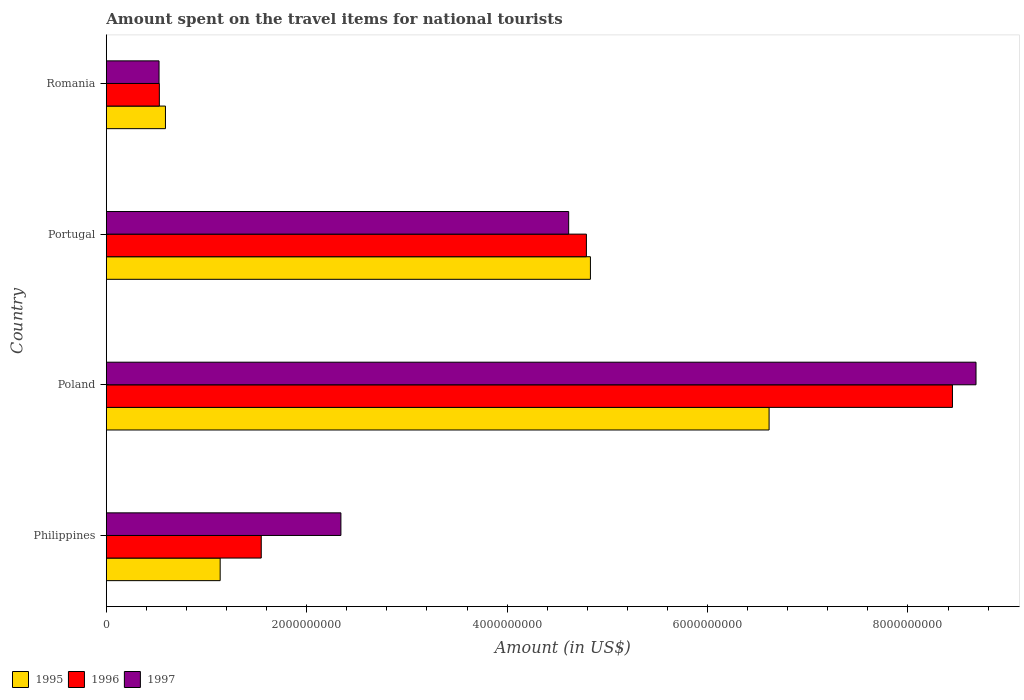How many groups of bars are there?
Your answer should be compact. 4. What is the label of the 4th group of bars from the top?
Provide a short and direct response. Philippines. In how many cases, is the number of bars for a given country not equal to the number of legend labels?
Ensure brevity in your answer.  0. What is the amount spent on the travel items for national tourists in 1995 in Poland?
Your answer should be compact. 6.61e+09. Across all countries, what is the maximum amount spent on the travel items for national tourists in 1996?
Ensure brevity in your answer.  8.44e+09. Across all countries, what is the minimum amount spent on the travel items for national tourists in 1996?
Offer a terse response. 5.29e+08. In which country was the amount spent on the travel items for national tourists in 1996 maximum?
Give a very brief answer. Poland. In which country was the amount spent on the travel items for national tourists in 1996 minimum?
Give a very brief answer. Romania. What is the total amount spent on the travel items for national tourists in 1997 in the graph?
Offer a very short reply. 1.62e+1. What is the difference between the amount spent on the travel items for national tourists in 1995 in Philippines and that in Portugal?
Provide a short and direct response. -3.70e+09. What is the difference between the amount spent on the travel items for national tourists in 1996 in Romania and the amount spent on the travel items for national tourists in 1995 in Portugal?
Make the answer very short. -4.30e+09. What is the average amount spent on the travel items for national tourists in 1996 per country?
Give a very brief answer. 3.83e+09. What is the difference between the amount spent on the travel items for national tourists in 1997 and amount spent on the travel items for national tourists in 1996 in Romania?
Your answer should be very brief. -3.00e+06. What is the ratio of the amount spent on the travel items for national tourists in 1995 in Philippines to that in Romania?
Offer a terse response. 1.93. Is the amount spent on the travel items for national tourists in 1997 in Poland less than that in Romania?
Provide a short and direct response. No. What is the difference between the highest and the second highest amount spent on the travel items for national tourists in 1995?
Your answer should be very brief. 1.78e+09. What is the difference between the highest and the lowest amount spent on the travel items for national tourists in 1996?
Ensure brevity in your answer.  7.92e+09. What does the 1st bar from the bottom in Portugal represents?
Keep it short and to the point. 1995. Is it the case that in every country, the sum of the amount spent on the travel items for national tourists in 1997 and amount spent on the travel items for national tourists in 1995 is greater than the amount spent on the travel items for national tourists in 1996?
Provide a succinct answer. Yes. How many bars are there?
Ensure brevity in your answer.  12. How are the legend labels stacked?
Your answer should be very brief. Horizontal. What is the title of the graph?
Your answer should be compact. Amount spent on the travel items for national tourists. What is the label or title of the X-axis?
Give a very brief answer. Amount (in US$). What is the label or title of the Y-axis?
Ensure brevity in your answer.  Country. What is the Amount (in US$) of 1995 in Philippines?
Provide a succinct answer. 1.14e+09. What is the Amount (in US$) of 1996 in Philippines?
Provide a succinct answer. 1.55e+09. What is the Amount (in US$) of 1997 in Philippines?
Your answer should be very brief. 2.34e+09. What is the Amount (in US$) in 1995 in Poland?
Provide a succinct answer. 6.61e+09. What is the Amount (in US$) in 1996 in Poland?
Make the answer very short. 8.44e+09. What is the Amount (in US$) in 1997 in Poland?
Make the answer very short. 8.68e+09. What is the Amount (in US$) of 1995 in Portugal?
Provide a succinct answer. 4.83e+09. What is the Amount (in US$) in 1996 in Portugal?
Make the answer very short. 4.79e+09. What is the Amount (in US$) in 1997 in Portugal?
Your response must be concise. 4.61e+09. What is the Amount (in US$) in 1995 in Romania?
Offer a terse response. 5.90e+08. What is the Amount (in US$) in 1996 in Romania?
Provide a short and direct response. 5.29e+08. What is the Amount (in US$) in 1997 in Romania?
Your answer should be very brief. 5.26e+08. Across all countries, what is the maximum Amount (in US$) in 1995?
Give a very brief answer. 6.61e+09. Across all countries, what is the maximum Amount (in US$) of 1996?
Keep it short and to the point. 8.44e+09. Across all countries, what is the maximum Amount (in US$) in 1997?
Your response must be concise. 8.68e+09. Across all countries, what is the minimum Amount (in US$) of 1995?
Your answer should be compact. 5.90e+08. Across all countries, what is the minimum Amount (in US$) in 1996?
Your response must be concise. 5.29e+08. Across all countries, what is the minimum Amount (in US$) of 1997?
Provide a short and direct response. 5.26e+08. What is the total Amount (in US$) in 1995 in the graph?
Make the answer very short. 1.32e+1. What is the total Amount (in US$) of 1996 in the graph?
Your answer should be compact. 1.53e+1. What is the total Amount (in US$) of 1997 in the graph?
Make the answer very short. 1.62e+1. What is the difference between the Amount (in US$) of 1995 in Philippines and that in Poland?
Provide a short and direct response. -5.48e+09. What is the difference between the Amount (in US$) in 1996 in Philippines and that in Poland?
Give a very brief answer. -6.90e+09. What is the difference between the Amount (in US$) of 1997 in Philippines and that in Poland?
Keep it short and to the point. -6.34e+09. What is the difference between the Amount (in US$) of 1995 in Philippines and that in Portugal?
Provide a short and direct response. -3.70e+09. What is the difference between the Amount (in US$) of 1996 in Philippines and that in Portugal?
Provide a succinct answer. -3.24e+09. What is the difference between the Amount (in US$) of 1997 in Philippines and that in Portugal?
Make the answer very short. -2.27e+09. What is the difference between the Amount (in US$) of 1995 in Philippines and that in Romania?
Give a very brief answer. 5.46e+08. What is the difference between the Amount (in US$) of 1996 in Philippines and that in Romania?
Keep it short and to the point. 1.02e+09. What is the difference between the Amount (in US$) in 1997 in Philippines and that in Romania?
Offer a very short reply. 1.82e+09. What is the difference between the Amount (in US$) in 1995 in Poland and that in Portugal?
Give a very brief answer. 1.78e+09. What is the difference between the Amount (in US$) in 1996 in Poland and that in Portugal?
Your answer should be compact. 3.65e+09. What is the difference between the Amount (in US$) in 1997 in Poland and that in Portugal?
Offer a terse response. 4.06e+09. What is the difference between the Amount (in US$) of 1995 in Poland and that in Romania?
Provide a succinct answer. 6.02e+09. What is the difference between the Amount (in US$) of 1996 in Poland and that in Romania?
Your answer should be compact. 7.92e+09. What is the difference between the Amount (in US$) of 1997 in Poland and that in Romania?
Offer a terse response. 8.15e+09. What is the difference between the Amount (in US$) in 1995 in Portugal and that in Romania?
Offer a very short reply. 4.24e+09. What is the difference between the Amount (in US$) in 1996 in Portugal and that in Romania?
Your response must be concise. 4.26e+09. What is the difference between the Amount (in US$) in 1997 in Portugal and that in Romania?
Provide a succinct answer. 4.09e+09. What is the difference between the Amount (in US$) of 1995 in Philippines and the Amount (in US$) of 1996 in Poland?
Your response must be concise. -7.31e+09. What is the difference between the Amount (in US$) in 1995 in Philippines and the Amount (in US$) in 1997 in Poland?
Keep it short and to the point. -7.54e+09. What is the difference between the Amount (in US$) of 1996 in Philippines and the Amount (in US$) of 1997 in Poland?
Make the answer very short. -7.13e+09. What is the difference between the Amount (in US$) in 1995 in Philippines and the Amount (in US$) in 1996 in Portugal?
Provide a short and direct response. -3.66e+09. What is the difference between the Amount (in US$) of 1995 in Philippines and the Amount (in US$) of 1997 in Portugal?
Provide a succinct answer. -3.48e+09. What is the difference between the Amount (in US$) of 1996 in Philippines and the Amount (in US$) of 1997 in Portugal?
Offer a very short reply. -3.07e+09. What is the difference between the Amount (in US$) in 1995 in Philippines and the Amount (in US$) in 1996 in Romania?
Make the answer very short. 6.07e+08. What is the difference between the Amount (in US$) in 1995 in Philippines and the Amount (in US$) in 1997 in Romania?
Offer a very short reply. 6.10e+08. What is the difference between the Amount (in US$) in 1996 in Philippines and the Amount (in US$) in 1997 in Romania?
Give a very brief answer. 1.02e+09. What is the difference between the Amount (in US$) in 1995 in Poland and the Amount (in US$) in 1996 in Portugal?
Keep it short and to the point. 1.82e+09. What is the difference between the Amount (in US$) in 1996 in Poland and the Amount (in US$) in 1997 in Portugal?
Your answer should be very brief. 3.83e+09. What is the difference between the Amount (in US$) in 1995 in Poland and the Amount (in US$) in 1996 in Romania?
Offer a terse response. 6.08e+09. What is the difference between the Amount (in US$) in 1995 in Poland and the Amount (in US$) in 1997 in Romania?
Your answer should be compact. 6.09e+09. What is the difference between the Amount (in US$) of 1996 in Poland and the Amount (in US$) of 1997 in Romania?
Provide a succinct answer. 7.92e+09. What is the difference between the Amount (in US$) of 1995 in Portugal and the Amount (in US$) of 1996 in Romania?
Your answer should be very brief. 4.30e+09. What is the difference between the Amount (in US$) of 1995 in Portugal and the Amount (in US$) of 1997 in Romania?
Give a very brief answer. 4.30e+09. What is the difference between the Amount (in US$) of 1996 in Portugal and the Amount (in US$) of 1997 in Romania?
Keep it short and to the point. 4.26e+09. What is the average Amount (in US$) in 1995 per country?
Your response must be concise. 3.29e+09. What is the average Amount (in US$) in 1996 per country?
Make the answer very short. 3.83e+09. What is the average Amount (in US$) of 1997 per country?
Provide a short and direct response. 4.04e+09. What is the difference between the Amount (in US$) in 1995 and Amount (in US$) in 1996 in Philippines?
Provide a succinct answer. -4.10e+08. What is the difference between the Amount (in US$) of 1995 and Amount (in US$) of 1997 in Philippines?
Your answer should be very brief. -1.20e+09. What is the difference between the Amount (in US$) in 1996 and Amount (in US$) in 1997 in Philippines?
Your response must be concise. -7.95e+08. What is the difference between the Amount (in US$) of 1995 and Amount (in US$) of 1996 in Poland?
Give a very brief answer. -1.83e+09. What is the difference between the Amount (in US$) in 1995 and Amount (in US$) in 1997 in Poland?
Your response must be concise. -2.06e+09. What is the difference between the Amount (in US$) in 1996 and Amount (in US$) in 1997 in Poland?
Offer a terse response. -2.35e+08. What is the difference between the Amount (in US$) in 1995 and Amount (in US$) in 1996 in Portugal?
Offer a terse response. 4.00e+07. What is the difference between the Amount (in US$) in 1995 and Amount (in US$) in 1997 in Portugal?
Provide a succinct answer. 2.17e+08. What is the difference between the Amount (in US$) in 1996 and Amount (in US$) in 1997 in Portugal?
Give a very brief answer. 1.77e+08. What is the difference between the Amount (in US$) of 1995 and Amount (in US$) of 1996 in Romania?
Provide a succinct answer. 6.10e+07. What is the difference between the Amount (in US$) in 1995 and Amount (in US$) in 1997 in Romania?
Make the answer very short. 6.40e+07. What is the difference between the Amount (in US$) of 1996 and Amount (in US$) of 1997 in Romania?
Provide a short and direct response. 3.00e+06. What is the ratio of the Amount (in US$) of 1995 in Philippines to that in Poland?
Your response must be concise. 0.17. What is the ratio of the Amount (in US$) of 1996 in Philippines to that in Poland?
Your answer should be compact. 0.18. What is the ratio of the Amount (in US$) in 1997 in Philippines to that in Poland?
Offer a terse response. 0.27. What is the ratio of the Amount (in US$) of 1995 in Philippines to that in Portugal?
Ensure brevity in your answer.  0.24. What is the ratio of the Amount (in US$) in 1996 in Philippines to that in Portugal?
Your answer should be compact. 0.32. What is the ratio of the Amount (in US$) of 1997 in Philippines to that in Portugal?
Provide a succinct answer. 0.51. What is the ratio of the Amount (in US$) in 1995 in Philippines to that in Romania?
Your answer should be compact. 1.93. What is the ratio of the Amount (in US$) in 1996 in Philippines to that in Romania?
Keep it short and to the point. 2.92. What is the ratio of the Amount (in US$) of 1997 in Philippines to that in Romania?
Keep it short and to the point. 4.45. What is the ratio of the Amount (in US$) in 1995 in Poland to that in Portugal?
Your answer should be very brief. 1.37. What is the ratio of the Amount (in US$) of 1996 in Poland to that in Portugal?
Ensure brevity in your answer.  1.76. What is the ratio of the Amount (in US$) in 1997 in Poland to that in Portugal?
Offer a very short reply. 1.88. What is the ratio of the Amount (in US$) of 1995 in Poland to that in Romania?
Make the answer very short. 11.21. What is the ratio of the Amount (in US$) in 1996 in Poland to that in Romania?
Offer a very short reply. 15.96. What is the ratio of the Amount (in US$) of 1997 in Poland to that in Romania?
Offer a terse response. 16.5. What is the ratio of the Amount (in US$) in 1995 in Portugal to that in Romania?
Your response must be concise. 8.19. What is the ratio of the Amount (in US$) of 1996 in Portugal to that in Romania?
Your answer should be very brief. 9.06. What is the ratio of the Amount (in US$) of 1997 in Portugal to that in Romania?
Your answer should be very brief. 8.77. What is the difference between the highest and the second highest Amount (in US$) in 1995?
Provide a short and direct response. 1.78e+09. What is the difference between the highest and the second highest Amount (in US$) of 1996?
Offer a terse response. 3.65e+09. What is the difference between the highest and the second highest Amount (in US$) of 1997?
Provide a short and direct response. 4.06e+09. What is the difference between the highest and the lowest Amount (in US$) in 1995?
Your response must be concise. 6.02e+09. What is the difference between the highest and the lowest Amount (in US$) in 1996?
Ensure brevity in your answer.  7.92e+09. What is the difference between the highest and the lowest Amount (in US$) of 1997?
Ensure brevity in your answer.  8.15e+09. 